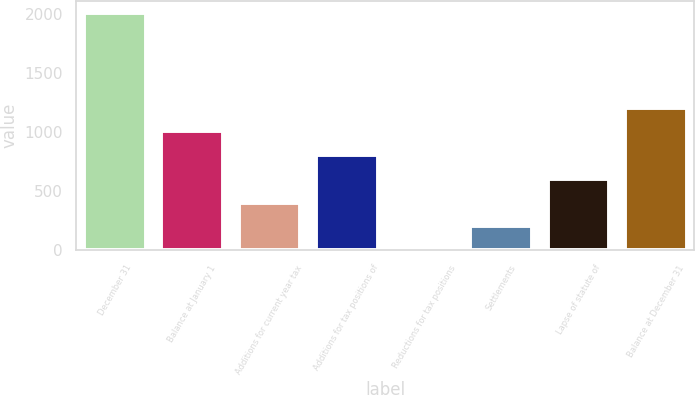<chart> <loc_0><loc_0><loc_500><loc_500><bar_chart><fcel>December 31<fcel>Balance at January 1<fcel>Additions for current year tax<fcel>Additions for tax positions of<fcel>Reductions for tax positions<fcel>Settlements<fcel>Lapse of statute of<fcel>Balance at December 31<nl><fcel>2014<fcel>1008<fcel>404.4<fcel>806.8<fcel>2<fcel>203.2<fcel>605.6<fcel>1209.2<nl></chart> 